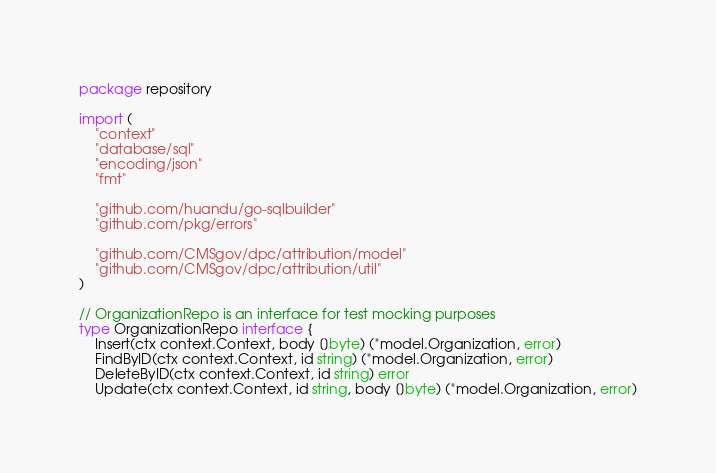Convert code to text. <code><loc_0><loc_0><loc_500><loc_500><_Go_>package repository

import (
	"context"
	"database/sql"
	"encoding/json"
	"fmt"

	"github.com/huandu/go-sqlbuilder"
	"github.com/pkg/errors"

	"github.com/CMSgov/dpc/attribution/model"
	"github.com/CMSgov/dpc/attribution/util"
)

// OrganizationRepo is an interface for test mocking purposes
type OrganizationRepo interface {
	Insert(ctx context.Context, body []byte) (*model.Organization, error)
	FindByID(ctx context.Context, id string) (*model.Organization, error)
	DeleteByID(ctx context.Context, id string) error
	Update(ctx context.Context, id string, body []byte) (*model.Organization, error)</code> 